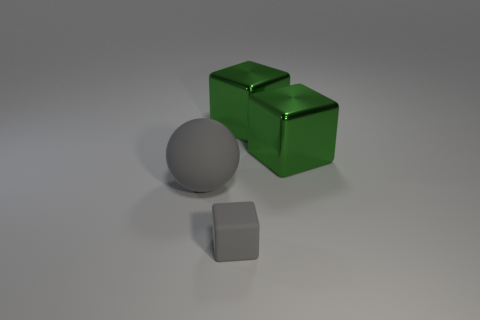Is there any other thing that is the same size as the matte block?
Offer a terse response. No. What color is the big sphere that is made of the same material as the small block?
Provide a succinct answer. Gray. Does the gray ball have the same size as the gray block?
Offer a very short reply. No. What material is the tiny gray object?
Provide a succinct answer. Rubber. Are there any balls of the same size as the gray block?
Your answer should be very brief. No. Are there the same number of gray spheres right of the rubber ball and cubes behind the tiny matte object?
Your response must be concise. No. Is the number of gray cubes greater than the number of tiny red rubber cubes?
Keep it short and to the point. Yes. What number of metal things are tiny gray cylinders or gray blocks?
Your response must be concise. 0. What number of matte balls have the same color as the rubber block?
Keep it short and to the point. 1. What is the gray thing in front of the large thing that is on the left side of the object that is in front of the matte ball made of?
Provide a short and direct response. Rubber. 